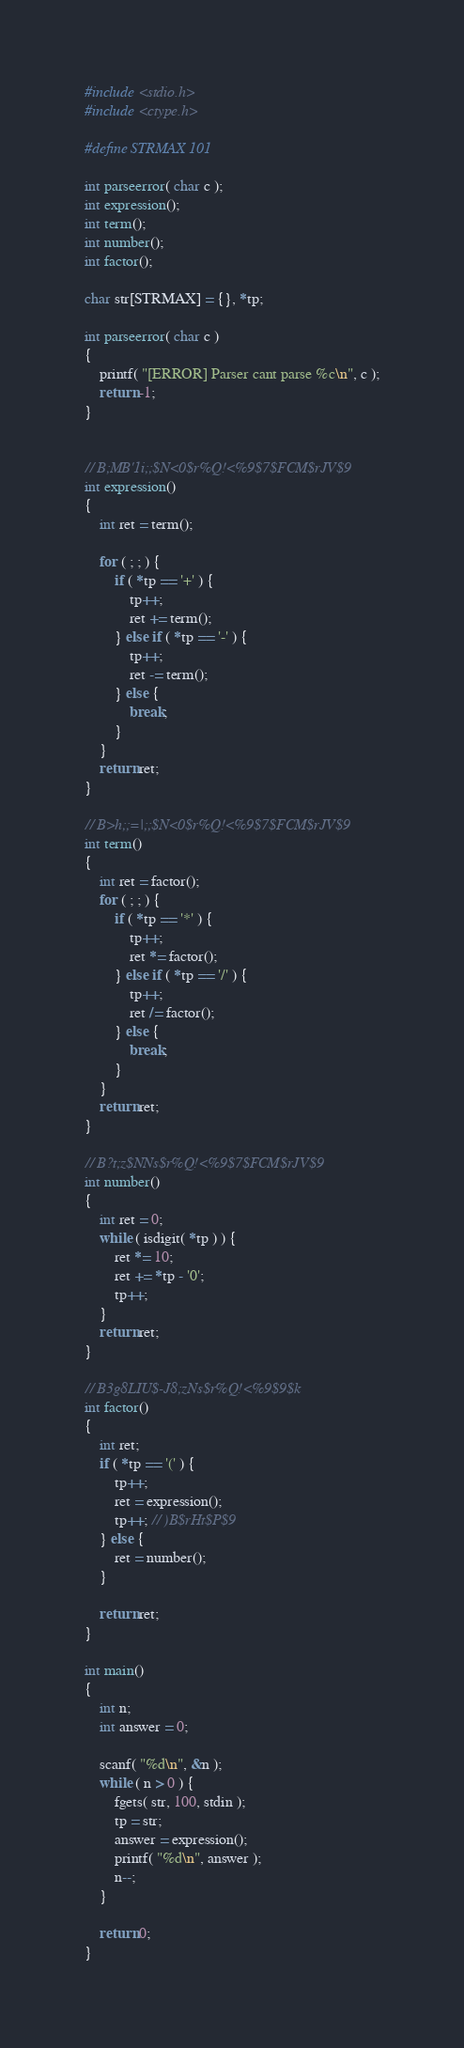<code> <loc_0><loc_0><loc_500><loc_500><_C_>#include <stdio.h>
#include <ctype.h>

#define STRMAX 101

int parseerror( char c );
int expression();
int term();
int number();
int factor();

char str[STRMAX] = {}, *tp;

int parseerror( char c )
{
	printf( "[ERROR] Parser cant parse %c\n", c );
	return -1;
}


// B;MB'1i;;$N<0$r%Q!<%9$7$FCM$rJV$9
int expression()
{
	int ret = term();

	for ( ; ; ) {
		if ( *tp == '+' ) {
			tp++;
			ret += term();
		} else if ( *tp == '-' ) {
			tp++;
			ret -= term();
		} else {
			break;
		}
	}
	return ret;
}

// B>h;;=|;;$N<0$r%Q!<%9$7$FCM$rJV$9
int term()
{
	int ret = factor();
	for ( ; ; ) {
		if ( *tp == '*' ) {
			tp++;
			ret *= factor();
		} else if ( *tp == '/' ) {
			tp++;
			ret /= factor();
		} else {
			break;
		}
	}
	return ret;
}

// B?t;z$NNs$r%Q!<%9$7$FCM$rJV$9
int number()
{
	int ret = 0;
	while ( isdigit( *tp ) ) {
		ret *= 10;
		ret += *tp - '0';
		tp++;
	}
	return ret;
}

// B3g8LIU$-J8;zNs$r%Q!<%9$9$k
int factor()
{
	int ret;
	if ( *tp == '(' ) {
		tp++;
		ret = expression();
		tp++; // )B$rHt$P$9
	} else {
		ret = number();
	}

	return ret;
}

int main()
{
	int n;
	int answer = 0;

	scanf( "%d\n", &n );
	while ( n > 0 ) {
		fgets( str, 100, stdin );
		tp = str;
		answer = expression();	
		printf( "%d\n", answer );	
		n--;
	}

	return 0;
}

</code> 